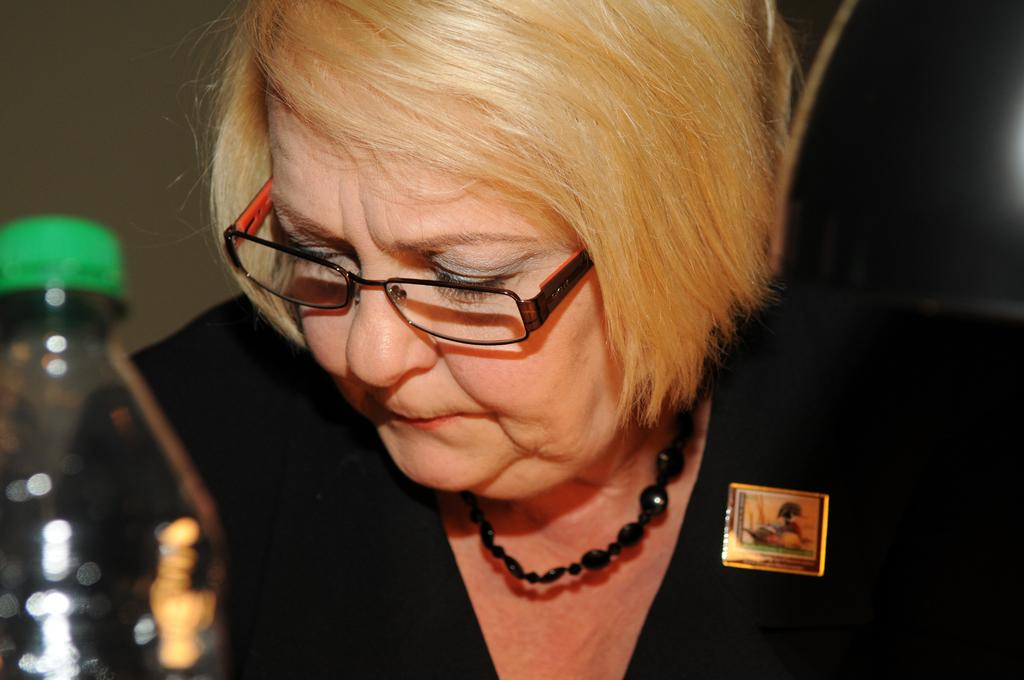Who is present in the image? There is a woman in the image. What is the woman wearing? The woman is wearing a black dress and spectacles. What object is in front of the woman? There is a bottle in front of the woman. What type of farm animals can be seen in the image? There are no farm animals present in the image. How many toes does the woman have in the image? The image does not show the woman's toes, so it cannot be determined from the image. 